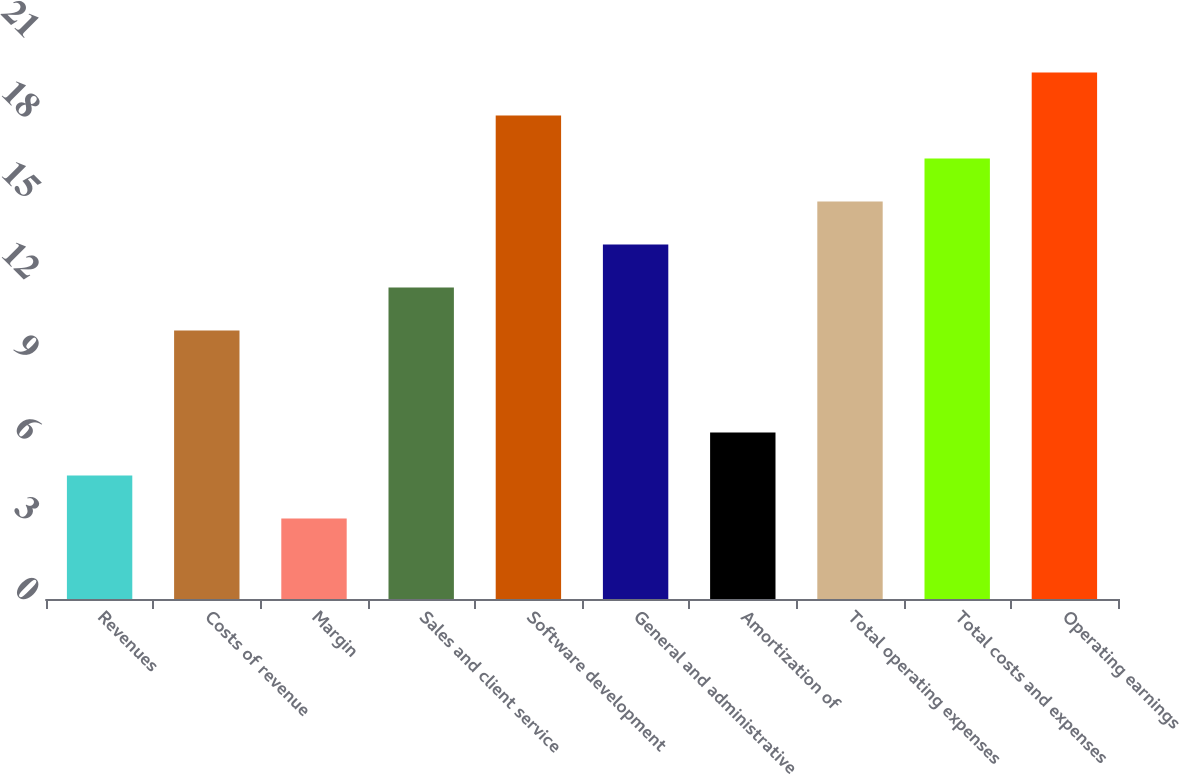Convert chart. <chart><loc_0><loc_0><loc_500><loc_500><bar_chart><fcel>Revenues<fcel>Costs of revenue<fcel>Margin<fcel>Sales and client service<fcel>Software development<fcel>General and administrative<fcel>Amortization of<fcel>Total operating expenses<fcel>Total costs and expenses<fcel>Operating earnings<nl><fcel>4.6<fcel>10<fcel>3<fcel>11.6<fcel>18<fcel>13.2<fcel>6.2<fcel>14.8<fcel>16.4<fcel>19.6<nl></chart> 